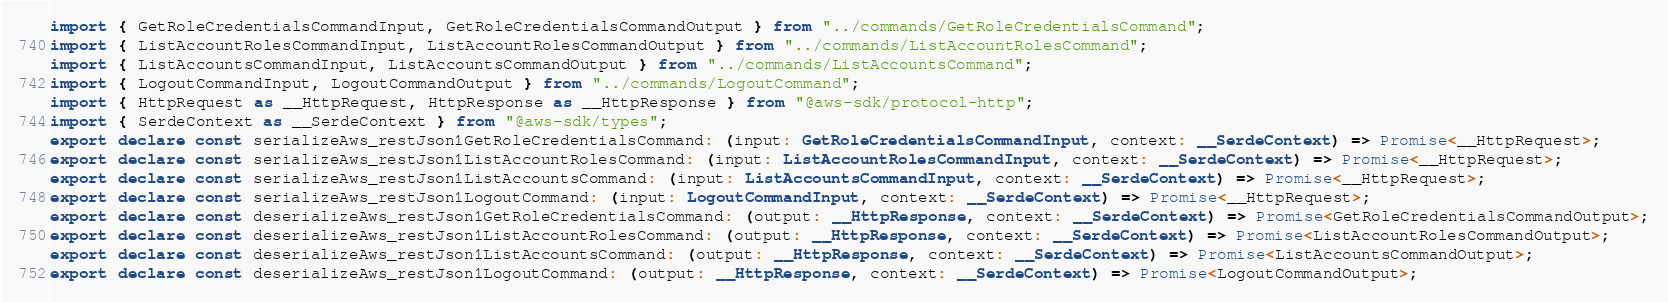Convert code to text. <code><loc_0><loc_0><loc_500><loc_500><_TypeScript_>import { GetRoleCredentialsCommandInput, GetRoleCredentialsCommandOutput } from "../commands/GetRoleCredentialsCommand";
import { ListAccountRolesCommandInput, ListAccountRolesCommandOutput } from "../commands/ListAccountRolesCommand";
import { ListAccountsCommandInput, ListAccountsCommandOutput } from "../commands/ListAccountsCommand";
import { LogoutCommandInput, LogoutCommandOutput } from "../commands/LogoutCommand";
import { HttpRequest as __HttpRequest, HttpResponse as __HttpResponse } from "@aws-sdk/protocol-http";
import { SerdeContext as __SerdeContext } from "@aws-sdk/types";
export declare const serializeAws_restJson1GetRoleCredentialsCommand: (input: GetRoleCredentialsCommandInput, context: __SerdeContext) => Promise<__HttpRequest>;
export declare const serializeAws_restJson1ListAccountRolesCommand: (input: ListAccountRolesCommandInput, context: __SerdeContext) => Promise<__HttpRequest>;
export declare const serializeAws_restJson1ListAccountsCommand: (input: ListAccountsCommandInput, context: __SerdeContext) => Promise<__HttpRequest>;
export declare const serializeAws_restJson1LogoutCommand: (input: LogoutCommandInput, context: __SerdeContext) => Promise<__HttpRequest>;
export declare const deserializeAws_restJson1GetRoleCredentialsCommand: (output: __HttpResponse, context: __SerdeContext) => Promise<GetRoleCredentialsCommandOutput>;
export declare const deserializeAws_restJson1ListAccountRolesCommand: (output: __HttpResponse, context: __SerdeContext) => Promise<ListAccountRolesCommandOutput>;
export declare const deserializeAws_restJson1ListAccountsCommand: (output: __HttpResponse, context: __SerdeContext) => Promise<ListAccountsCommandOutput>;
export declare const deserializeAws_restJson1LogoutCommand: (output: __HttpResponse, context: __SerdeContext) => Promise<LogoutCommandOutput>;
</code> 